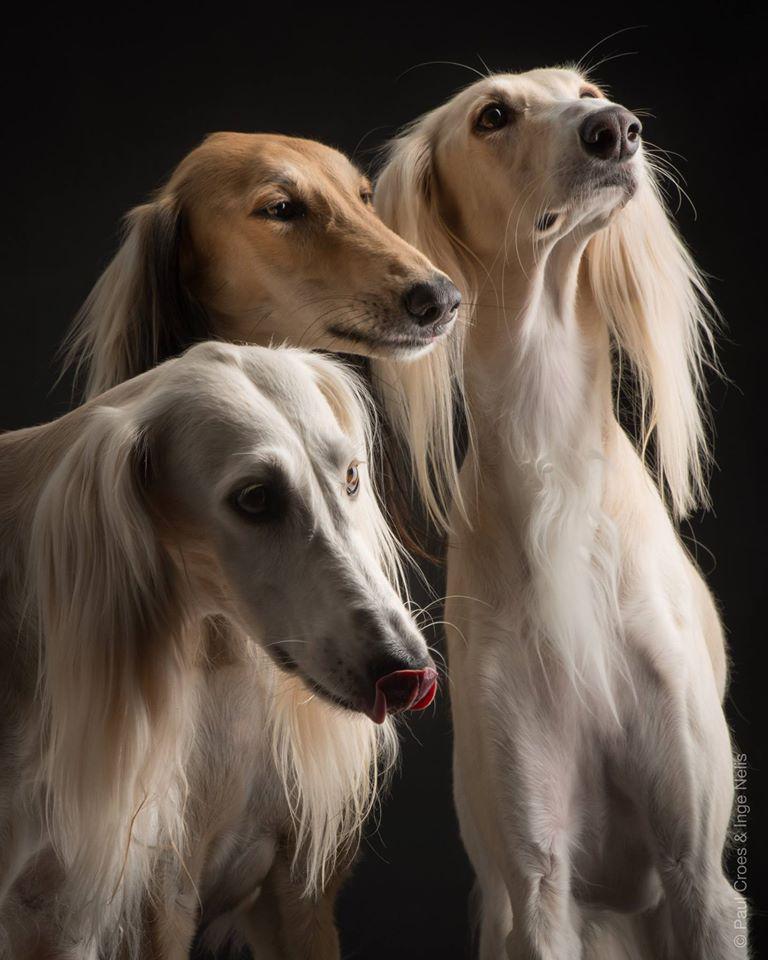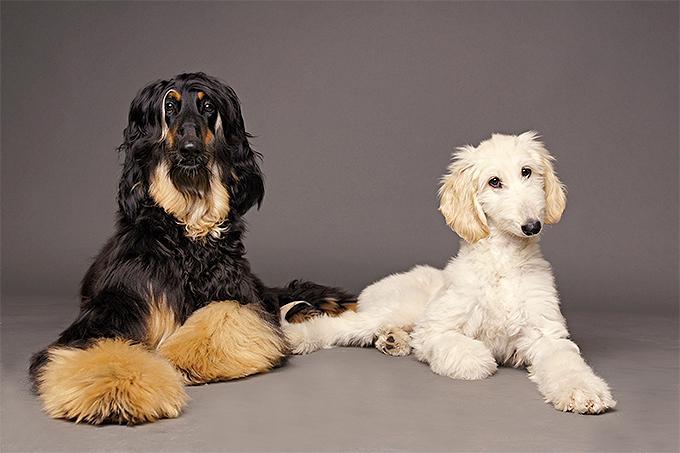The first image is the image on the left, the second image is the image on the right. Examine the images to the left and right. Is the description "A sitting dog in one image is wearing an ornate head covering that extends down its neck." accurate? Answer yes or no. No. 